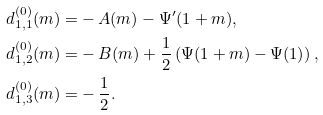Convert formula to latex. <formula><loc_0><loc_0><loc_500><loc_500>d ^ { ( 0 ) } _ { 1 , 1 } ( m ) = & - A ( m ) - \Psi ^ { \prime } ( 1 + m ) , \\ d ^ { ( 0 ) } _ { 1 , 2 } ( m ) = & - B ( m ) + \frac { 1 } { 2 } \left ( \Psi ( 1 + m ) - \Psi ( 1 ) \right ) , \\ d ^ { ( 0 ) } _ { 1 , 3 } ( m ) = & - \frac { 1 } { 2 } .</formula> 